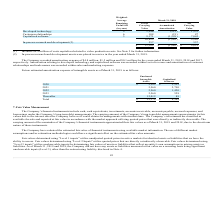According to Mimecast Limited's financial document, How much did the Company recorded amortization expense for the year ended March 31, 2019? According to the financial document, $4.8 million. The relevant text states: "The Company recorded amortization expense of $4.8 million, $1.5 million and $0.1 million for the years ended March 31, 2019, 2018 and 2017,..." Also, How much did the Company recorded amortization expense for the year ended March 31, 2018? According to the financial document, $1.5 million. The relevant text states: "any recorded amortization expense of $4.8 million, $1.5 million and $0.1 million for the years ended March 31, 2019, 2018 and 2017,..." Also, How much did the Company recorded amortization expense for the year ended March 31, 2017? According to the financial document, $0.1 million. The relevant text states: "tization expense of $4.8 million, $1.5 million and $0.1 million for the years ended March 31, 2019, 2018 and 2017,..." Also, can you calculate: What is the change in Capitalized Software from 2020 to 2021? Based on the calculation: 2,790-3,522, the result is -732. This is based on the information: "2020 $ 2,582 $ 3,522 2021 2,560 2,790..." The key data points involved are: 2,790, 3,522. Also, can you calculate: What is the change in Capitalized Software from 2021 to 2022? Based on the calculation: 1,420-2,790, the result is -1370. This is based on the information: "2022 2,560 1,420 2021 2,560 2,790..." The key data points involved are: 1,420, 2,790. Also, can you calculate: What is the change in Capitalized Software from 2022 to 2023? Based on the calculation: 528-1,420, the result is -892. This is based on the information: "2022 2,560 1,420 2023 2,560 528..." The key data points involved are: 1,420, 528. 